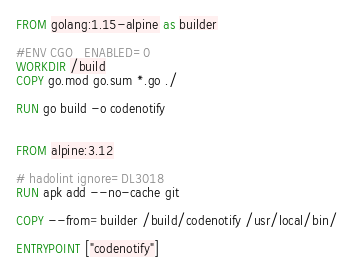<code> <loc_0><loc_0><loc_500><loc_500><_Dockerfile_>FROM golang:1.15-alpine as builder

#ENV CGO_ENABLED=0
WORKDIR /build
COPY go.mod go.sum *.go ./

RUN go build -o codenotify


FROM alpine:3.12

# hadolint ignore=DL3018
RUN apk add --no-cache git

COPY --from=builder /build/codenotify /usr/local/bin/

ENTRYPOINT ["codenotify"]
</code> 